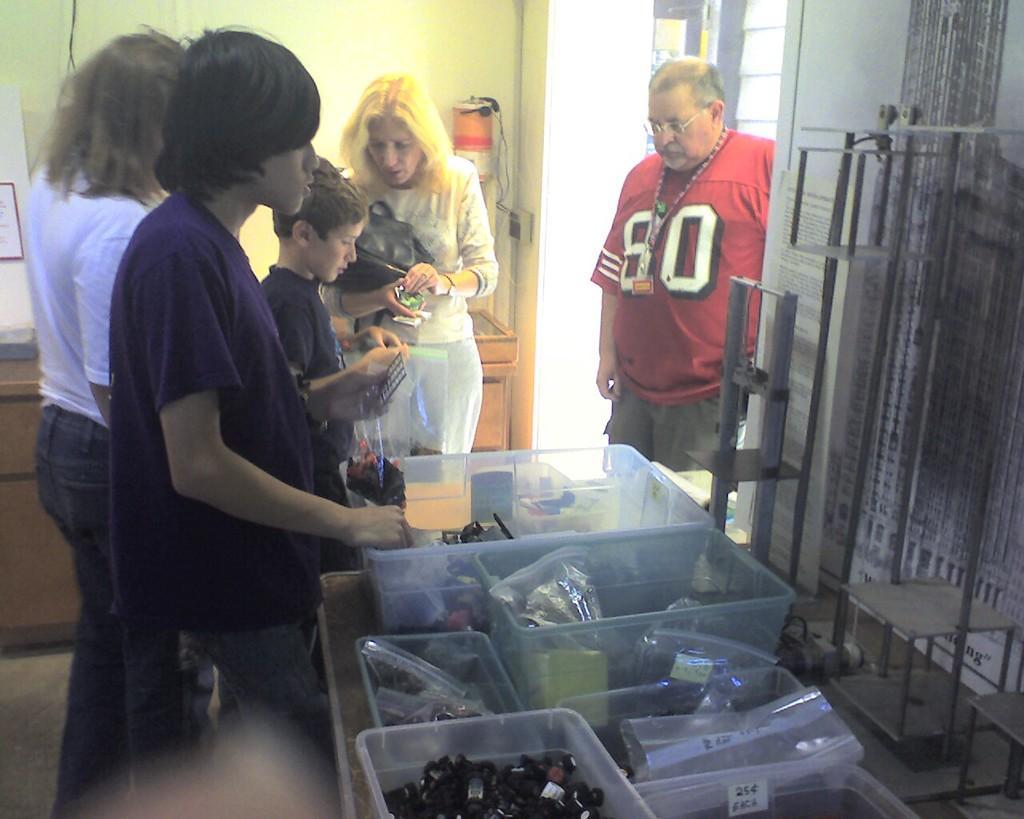Could you give a brief overview of what you see in this image? In the image we can see there are four people and a child standing, they are wearing clothes. This man is wearing neck chain and a spectacle. This is a handbag, boxes and in the box there are many other things. This is a floor and small ladder. 